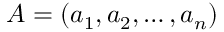<formula> <loc_0><loc_0><loc_500><loc_500>A = ( a _ { 1 } , a _ { 2 } , \dots , a _ { n } )</formula> 